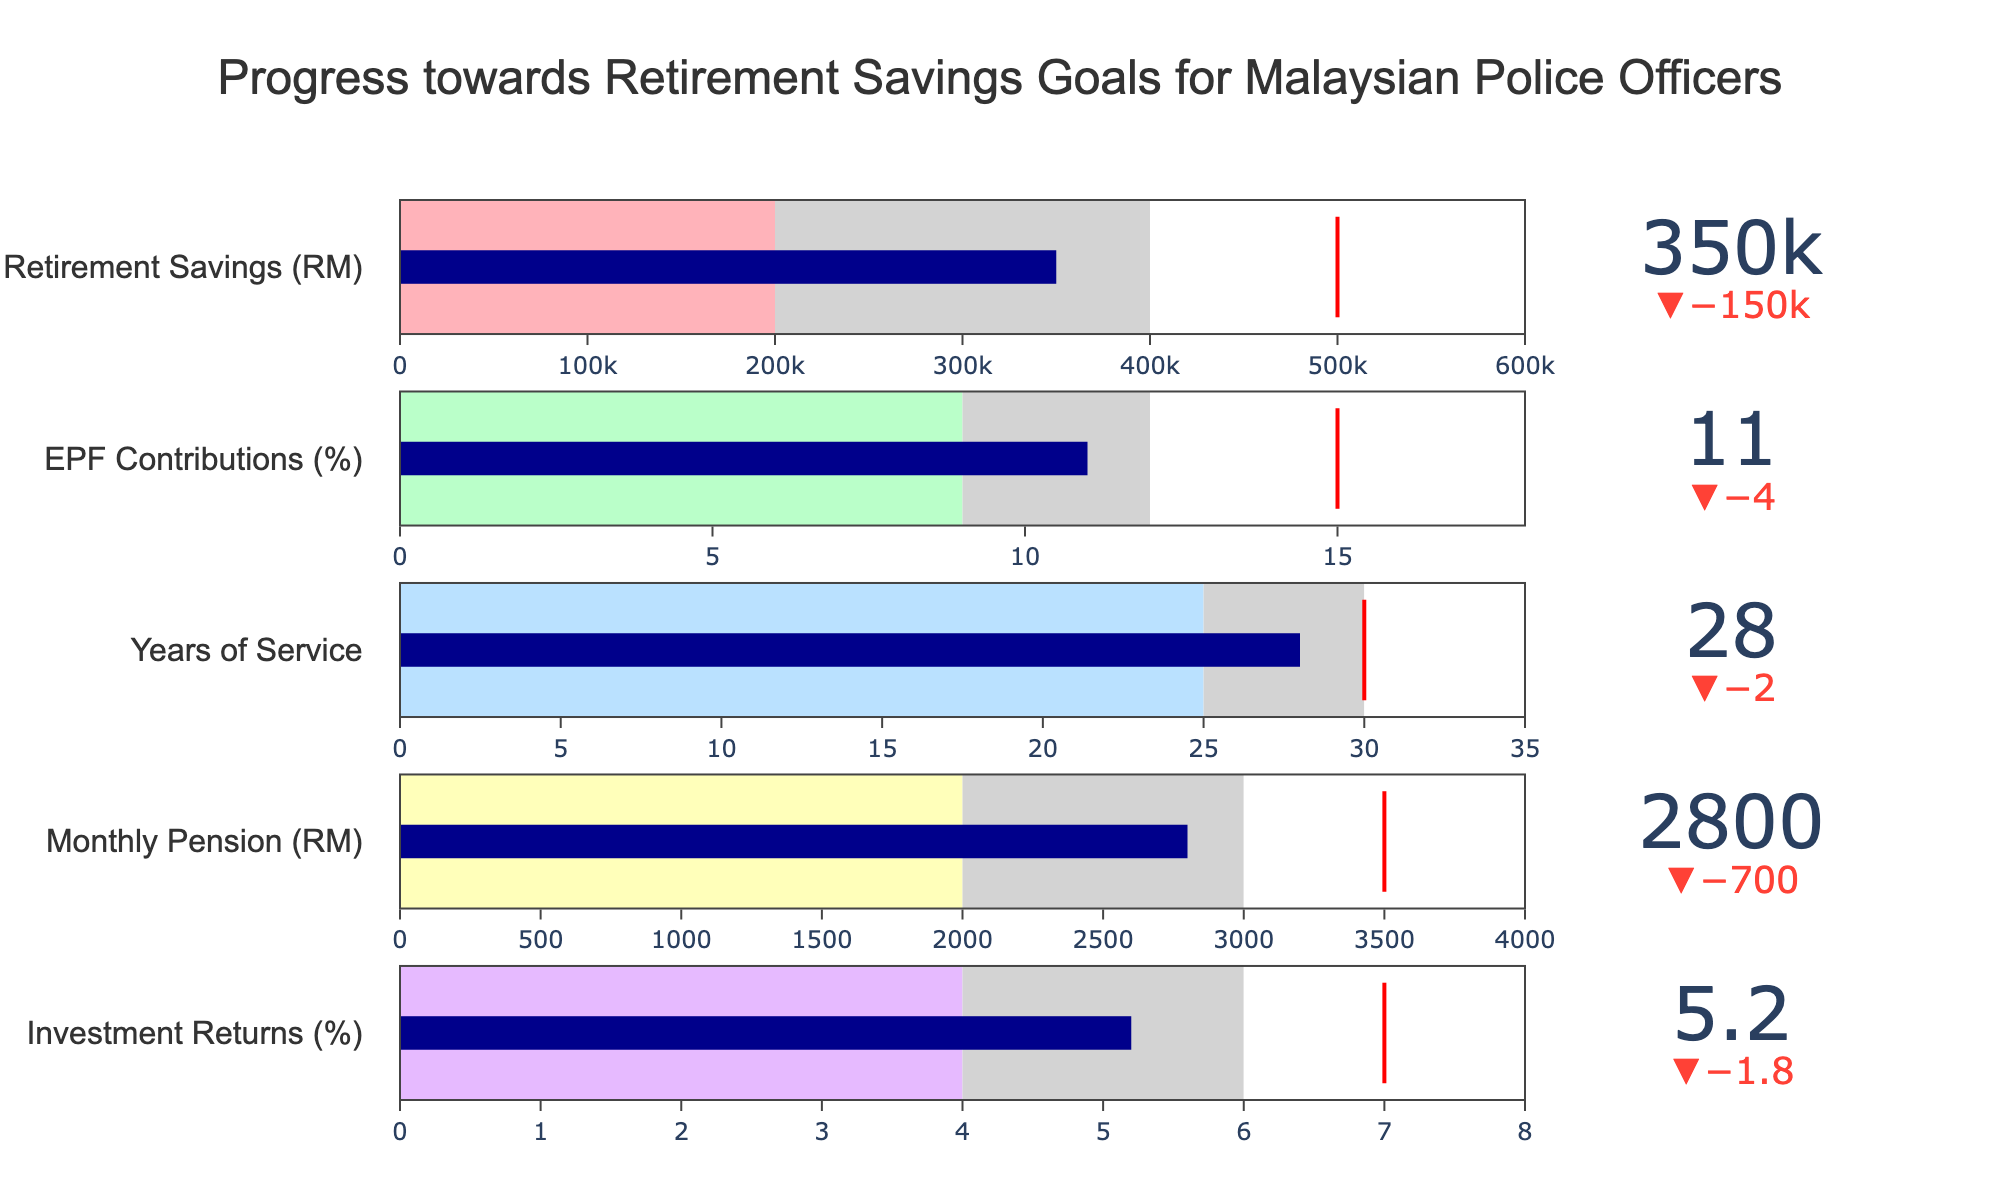What is the actual amount of retirement savings? The actual amount of retirement savings is displayed on the bullet chart and labeled as "Actual" for retirement savings.
Answer: 350,000 RM What is the target EPF contribution percentage? The bullet chart includes a reference (target) value for EPF Contributions, which is labeled as the target value.
Answer: 15% How much is the lower bound for the monthly pension range? The lower bound for the monthly pension range is labeled as "LowerBound" under the Monthly Pension in the bullet chart.
Answer: 2,000 RM Does the value of years of service exceed the target? To determine this, compare the actual value to the target value of years of service. The actual years of service (28) are less than the target (30).
Answer: No What is the difference between the actual retirement savings and the target? Subtract the actual retirement savings from the target: 500,000 RM (target) - 350,000 RM (actual).
Answer: 150,000 RM What percentage of the investment returns is between the lower and upper bounds? Investment returns are labeled with a lower bound of 4% and an upper bound of 8%, while the actual value is 5.2%. Since 5.2% lies between 4% and 8%, it is included.
Answer: 5.2% Among all the measured metrics, which one is the closest to its target? By comparing the actual values to their respective targets across all metrics, the EPF Contributions (11% actual vs 15% target, delta 4%) are the closest to their target.
Answer: EPF Contributions How much more do the retirement savings need to reach the upper bound? Subtract the actual retirement savings from the upper bound: 600,000 RM (upper bound) - 350,000 RM (actual).
Answer: 250,000 RM Which metric's actual value lies between the mid and upper bounds? For each metric, check if the actual value lies between the mid bound and upper bound. The only metric where this is true is Investment Returns (5.2% actual between 6% mid bound and 8% upper bound).
Answer: Investment Returns What is the average of the lower bounds for all the metrics? Add the lower bounds of all metrics and divide by the number of metrics: (200,000 + 9 + 25 + 2,000 + 4) / 5 = 202,038 / 5.
Answer: 40,407.6 